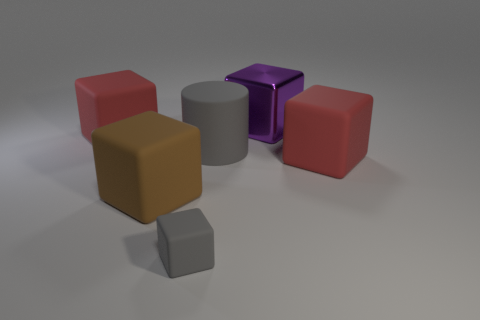Subtract all tiny gray matte blocks. How many blocks are left? 4 Subtract 2 cubes. How many cubes are left? 3 Subtract all purple cubes. How many cubes are left? 4 Add 1 big brown rubber cubes. How many objects exist? 7 Subtract all cylinders. How many objects are left? 5 Subtract all red balls. How many brown cubes are left? 1 Subtract all tiny gray rubber objects. Subtract all purple matte spheres. How many objects are left? 5 Add 1 large brown rubber objects. How many large brown rubber objects are left? 2 Add 5 red things. How many red things exist? 7 Subtract 0 cyan cylinders. How many objects are left? 6 